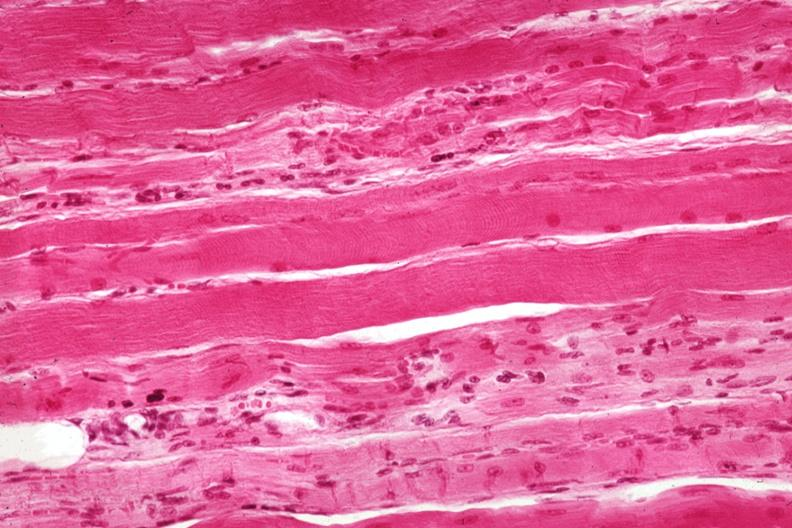s hemorrhage newborn present?
Answer the question using a single word or phrase. No 